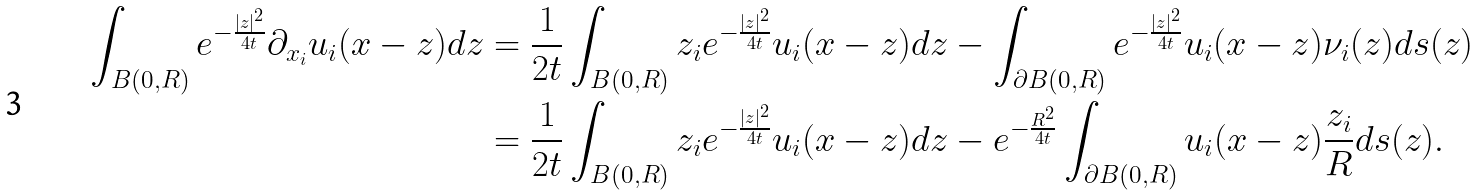<formula> <loc_0><loc_0><loc_500><loc_500>\int _ { B ( 0 , R ) } e ^ { - \frac { | z | ^ { 2 } } { 4 t } } \partial _ { x _ { i } } u _ { i } ( x - z ) d z & = \frac { 1 } { 2 t } \int _ { B ( 0 , R ) } z _ { i } e ^ { - \frac { | z | ^ { 2 } } { 4 t } } u _ { i } ( x - z ) d z - \int _ { \partial B ( 0 , R ) } e ^ { - \frac { | z | ^ { 2 } } { 4 t } } u _ { i } ( x - z ) \nu _ { i } ( z ) d s ( z ) \\ & = \frac { 1 } { 2 t } \int _ { B ( 0 , R ) } z _ { i } e ^ { - \frac { | z | ^ { 2 } } { 4 t } } u _ { i } ( x - z ) d z - e ^ { - \frac { R ^ { 2 } } { 4 t } } \int _ { \partial B ( 0 , R ) } u _ { i } ( x - z ) \frac { z _ { i } } { R } d s ( z ) .</formula> 